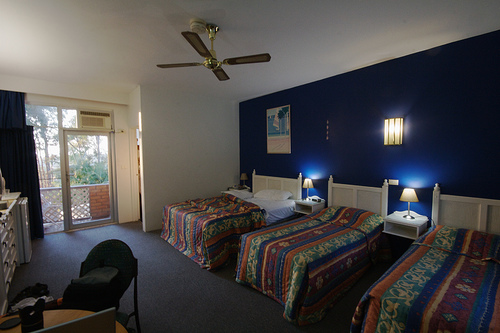<image>
Can you confirm if the lamp is on the table? No. The lamp is not positioned on the table. They may be near each other, but the lamp is not supported by or resting on top of the table. Where is the light in relation to the bed? Is it on the bed? No. The light is not positioned on the bed. They may be near each other, but the light is not supported by or resting on top of the bed. Where is the ceiling fan in relation to the bed? Is it above the bed? Yes. The ceiling fan is positioned above the bed in the vertical space, higher up in the scene. 